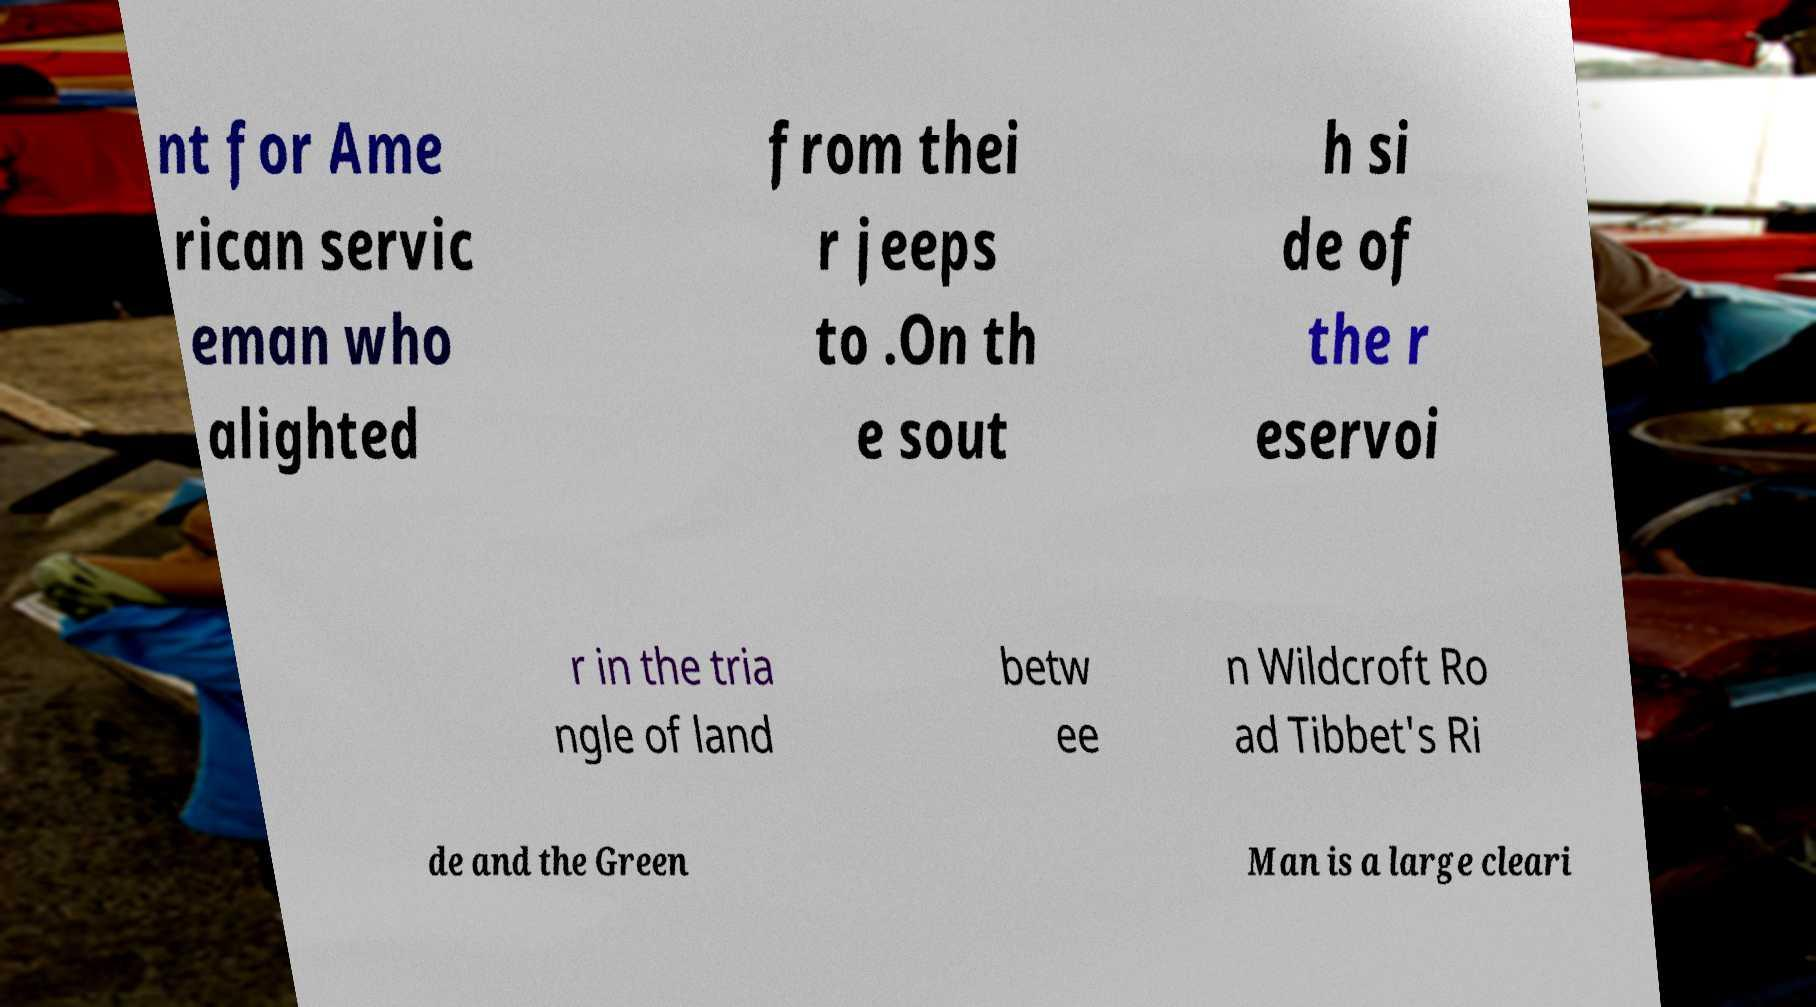Could you assist in decoding the text presented in this image and type it out clearly? nt for Ame rican servic eman who alighted from thei r jeeps to .On th e sout h si de of the r eservoi r in the tria ngle of land betw ee n Wildcroft Ro ad Tibbet's Ri de and the Green Man is a large cleari 